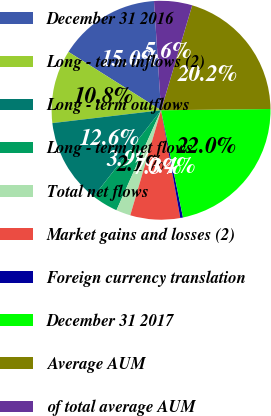Convert chart to OTSL. <chart><loc_0><loc_0><loc_500><loc_500><pie_chart><fcel>December 31 2016<fcel>Long - term inflows (2)<fcel>Long - term outflows<fcel>Long - term net flows<fcel>Total net flows<fcel>Market gains and losses (2)<fcel>Foreign currency translation<fcel>December 31 2017<fcel>Average AUM<fcel>of total average AUM<nl><fcel>15.02%<fcel>10.83%<fcel>12.57%<fcel>3.88%<fcel>2.14%<fcel>7.35%<fcel>0.4%<fcel>21.97%<fcel>20.23%<fcel>5.62%<nl></chart> 